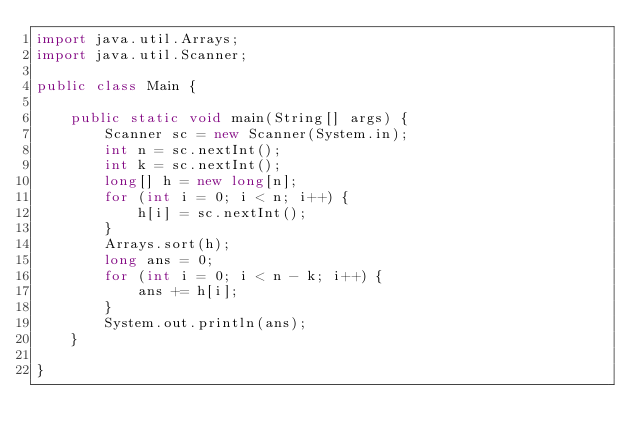<code> <loc_0><loc_0><loc_500><loc_500><_Java_>import java.util.Arrays;
import java.util.Scanner;

public class Main {

    public static void main(String[] args) {
        Scanner sc = new Scanner(System.in);
        int n = sc.nextInt();
        int k = sc.nextInt();
        long[] h = new long[n];
        for (int i = 0; i < n; i++) {
            h[i] = sc.nextInt();
        }
        Arrays.sort(h);
        long ans = 0;
        for (int i = 0; i < n - k; i++) {
            ans += h[i];
        }
        System.out.println(ans);
    }

}
</code> 